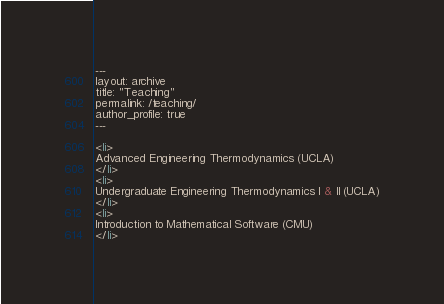Convert code to text. <code><loc_0><loc_0><loc_500><loc_500><_HTML_>---
layout: archive
title: "Teaching"
permalink: /teaching/
author_profile: true
---

<li>
Advanced Engineering Thermodynamics (UCLA)
</li>
<li>
Undergraduate Engineering Thermodynamics I & II (UCLA)
</li>
<li>
Introduction to Mathematical Software (CMU)
</li>
</code> 